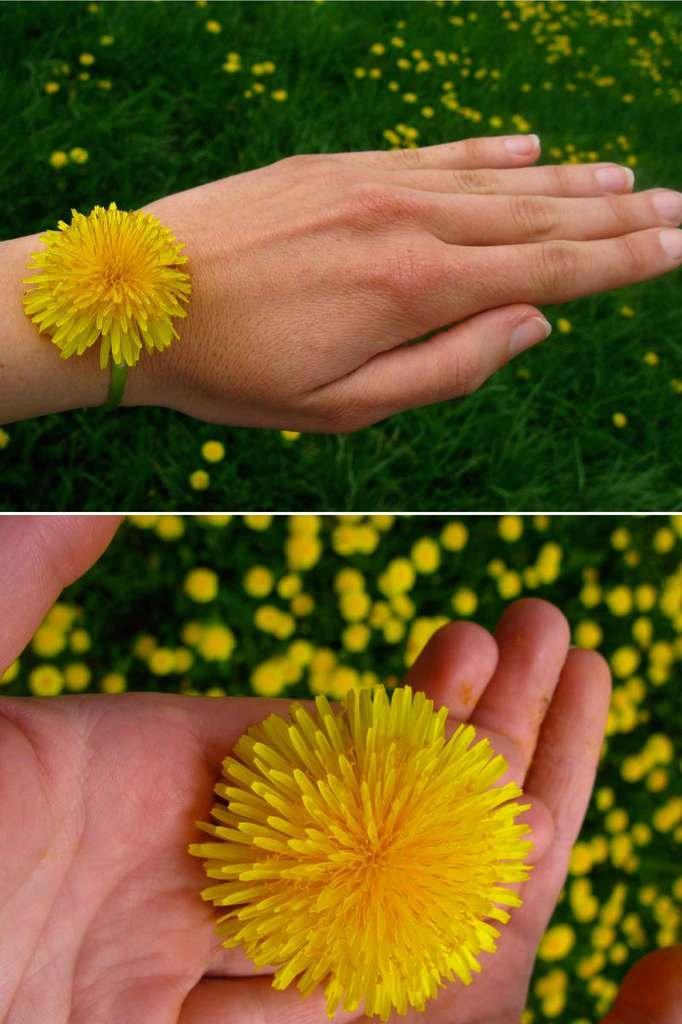Please provide a concise description of this image. In this picture I can see there is a flower in the hand and in the other picture the flower is tied to the hand and in the backdrop there are some plants with flowers. 